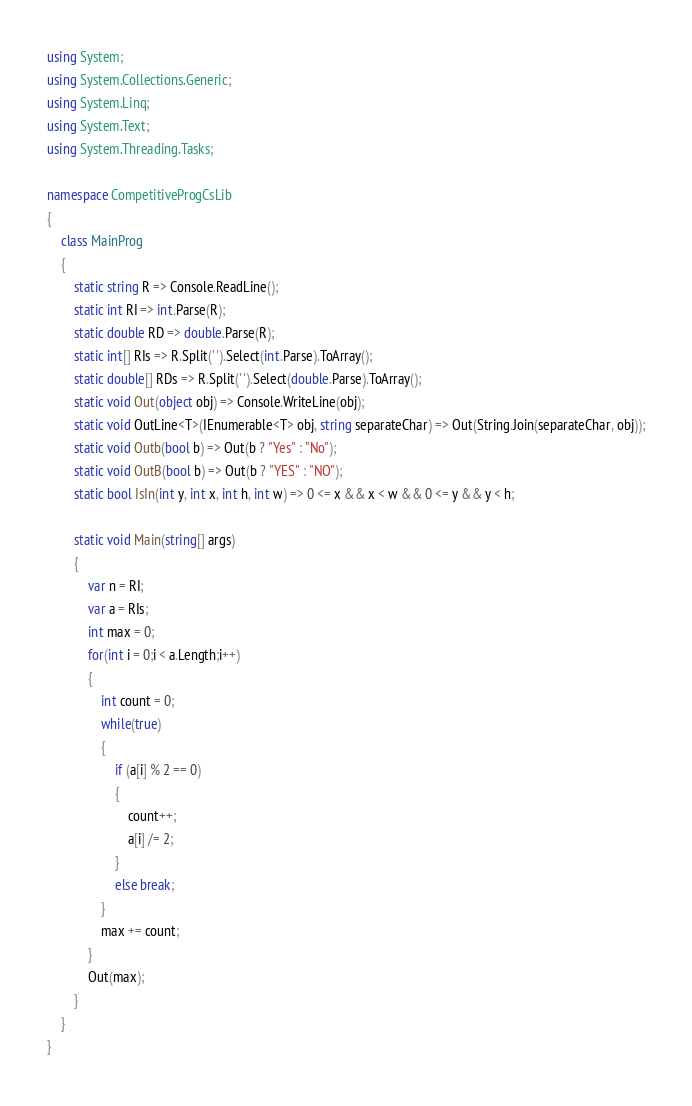Convert code to text. <code><loc_0><loc_0><loc_500><loc_500><_C#_>using System;
using System.Collections.Generic;
using System.Linq;
using System.Text;
using System.Threading.Tasks;

namespace CompetitiveProgCsLib
{
	class MainProg
	{
		static string R => Console.ReadLine();
		static int RI => int.Parse(R);
		static double RD => double.Parse(R);
		static int[] RIs => R.Split(' ').Select(int.Parse).ToArray();
		static double[] RDs => R.Split(' ').Select(double.Parse).ToArray();
		static void Out(object obj) => Console.WriteLine(obj);
		static void OutLine<T>(IEnumerable<T> obj, string separateChar) => Out(String.Join(separateChar, obj));
		static void Outb(bool b) => Out(b ? "Yes" : "No");
		static void OutB(bool b) => Out(b ? "YES" : "NO");
		static bool IsIn(int y, int x, int h, int w) => 0 <= x && x < w && 0 <= y && y < h;

		static void Main(string[] args)
		{
			var n = RI;
			var a = RIs;
			int max = 0;
			for(int i = 0;i < a.Length;i++)
			{
				int count = 0;
				while(true)
				{
					if (a[i] % 2 == 0)
					{
						count++;
						a[i] /= 2;
					}
					else break;
				}
				max += count;
			}
			Out(max);
		}
	}
}
</code> 